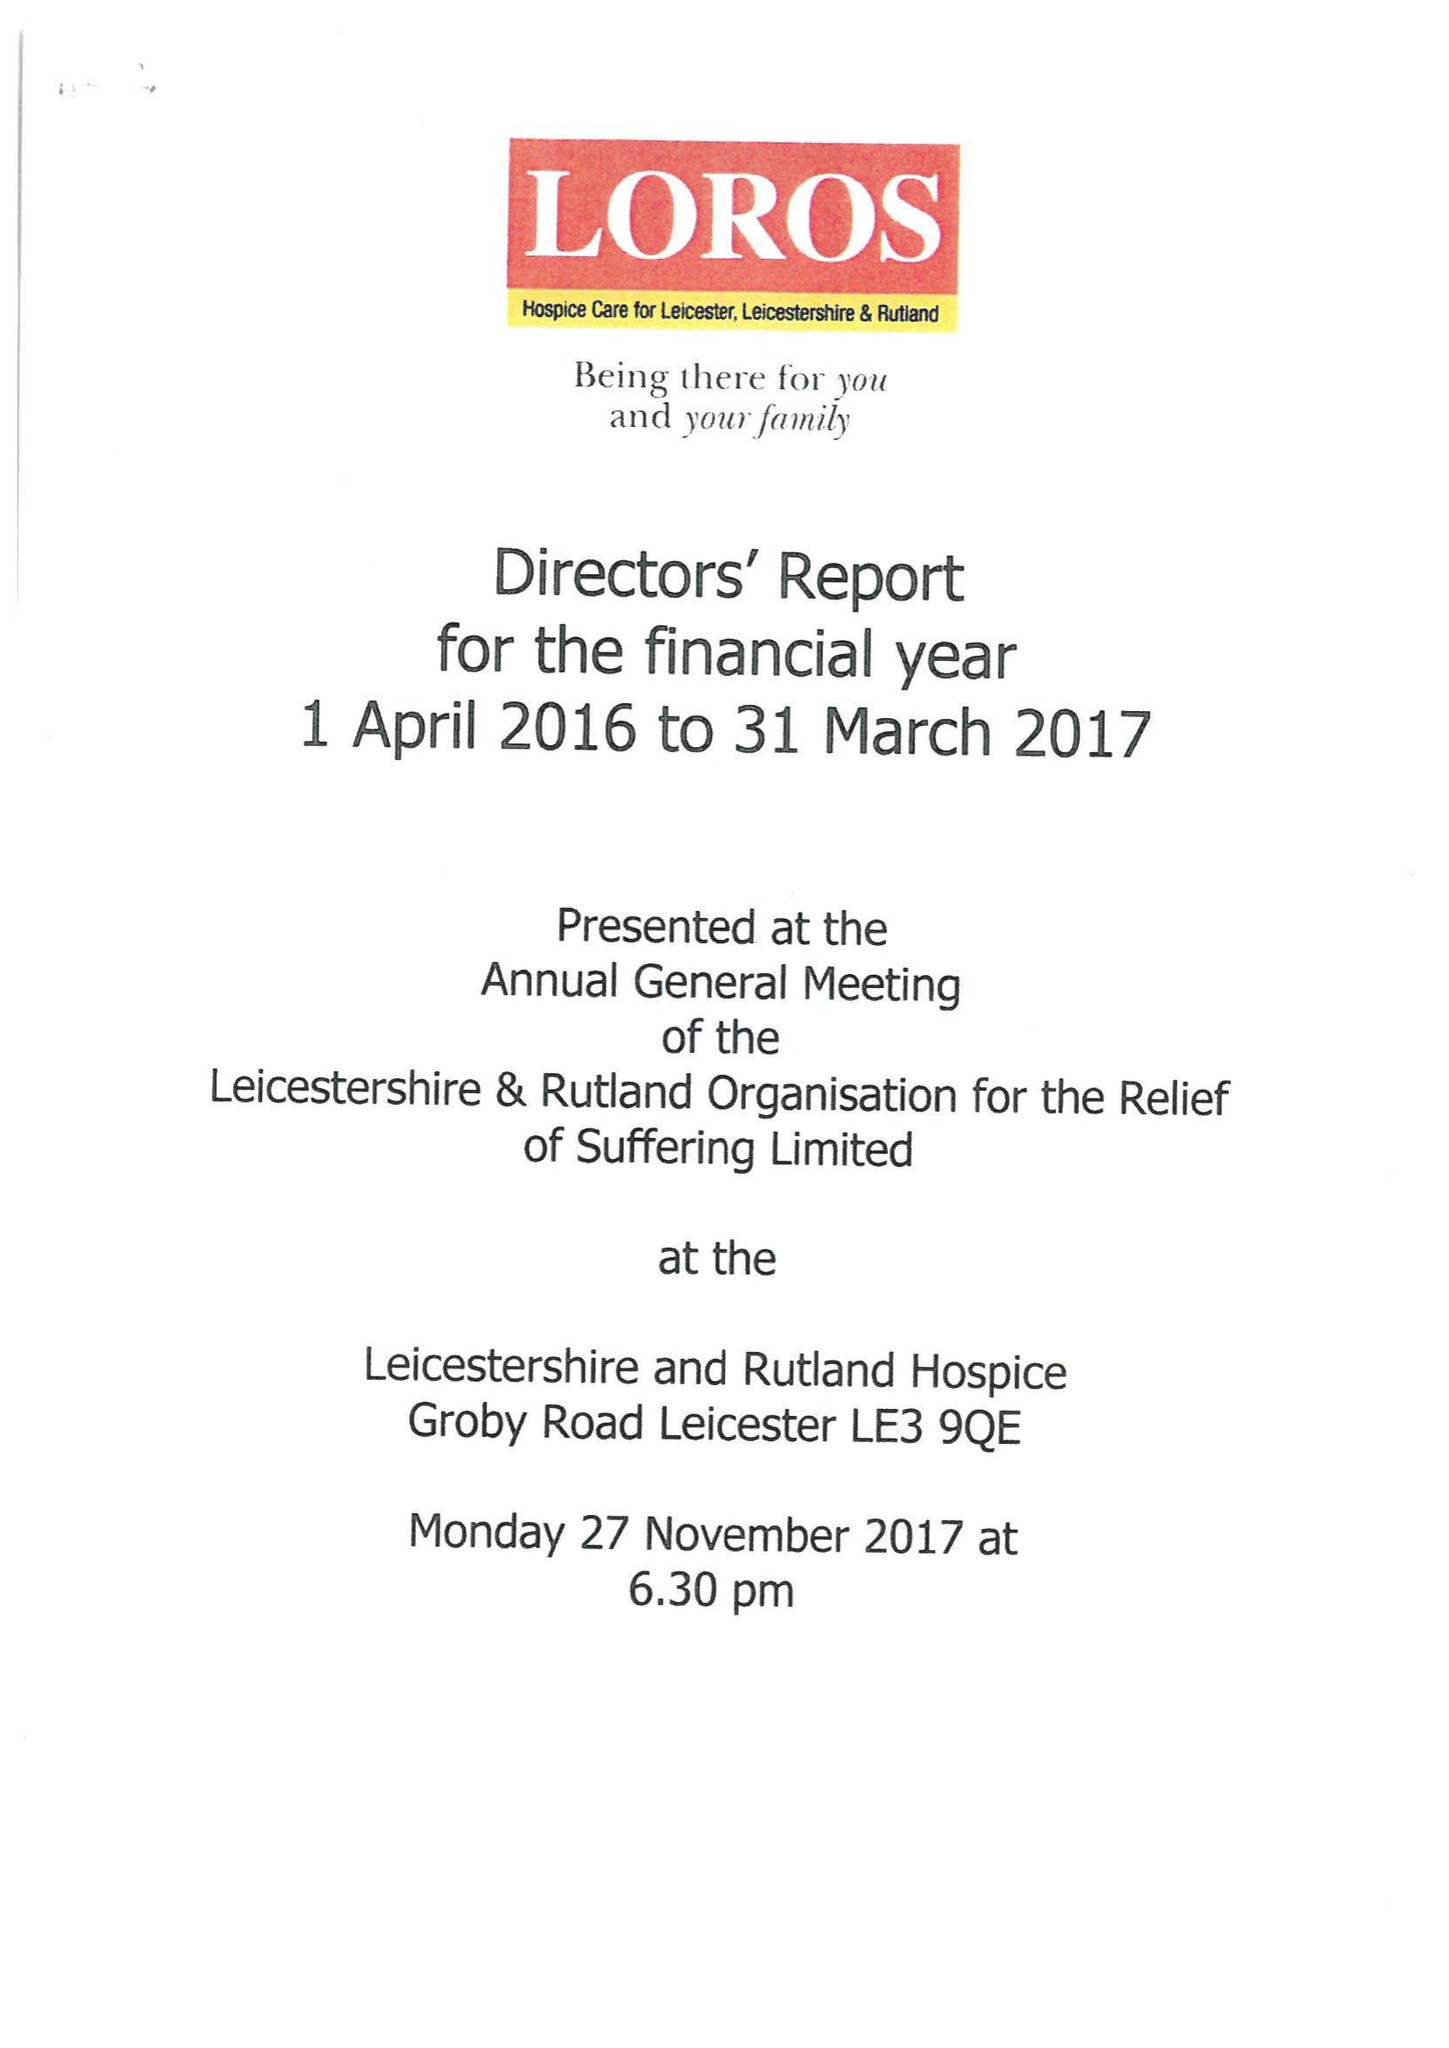What is the value for the address__post_town?
Answer the question using a single word or phrase. LEICESTER 